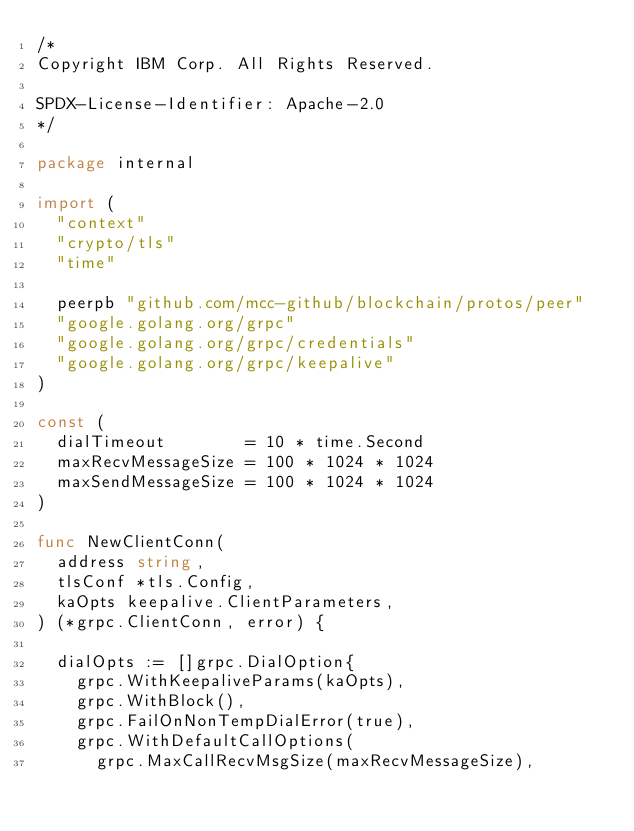<code> <loc_0><loc_0><loc_500><loc_500><_Go_>/*
Copyright IBM Corp. All Rights Reserved.

SPDX-License-Identifier: Apache-2.0
*/

package internal

import (
	"context"
	"crypto/tls"
	"time"

	peerpb "github.com/mcc-github/blockchain/protos/peer"
	"google.golang.org/grpc"
	"google.golang.org/grpc/credentials"
	"google.golang.org/grpc/keepalive"
)

const (
	dialTimeout        = 10 * time.Second
	maxRecvMessageSize = 100 * 1024 * 1024 
	maxSendMessageSize = 100 * 1024 * 1024 
)

func NewClientConn(
	address string,
	tlsConf *tls.Config,
	kaOpts keepalive.ClientParameters,
) (*grpc.ClientConn, error) {

	dialOpts := []grpc.DialOption{
		grpc.WithKeepaliveParams(kaOpts),
		grpc.WithBlock(),
		grpc.FailOnNonTempDialError(true),
		grpc.WithDefaultCallOptions(
			grpc.MaxCallRecvMsgSize(maxRecvMessageSize),</code> 